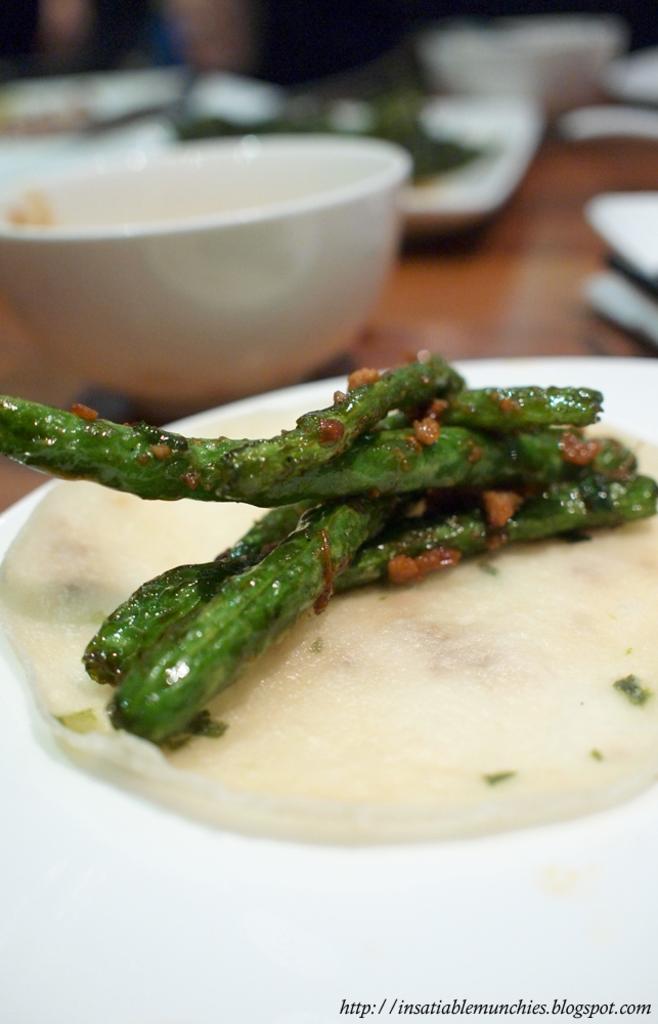Can you describe this image briefly? On this planet there is a food. Background it is blurry we can see plates and bowls. 